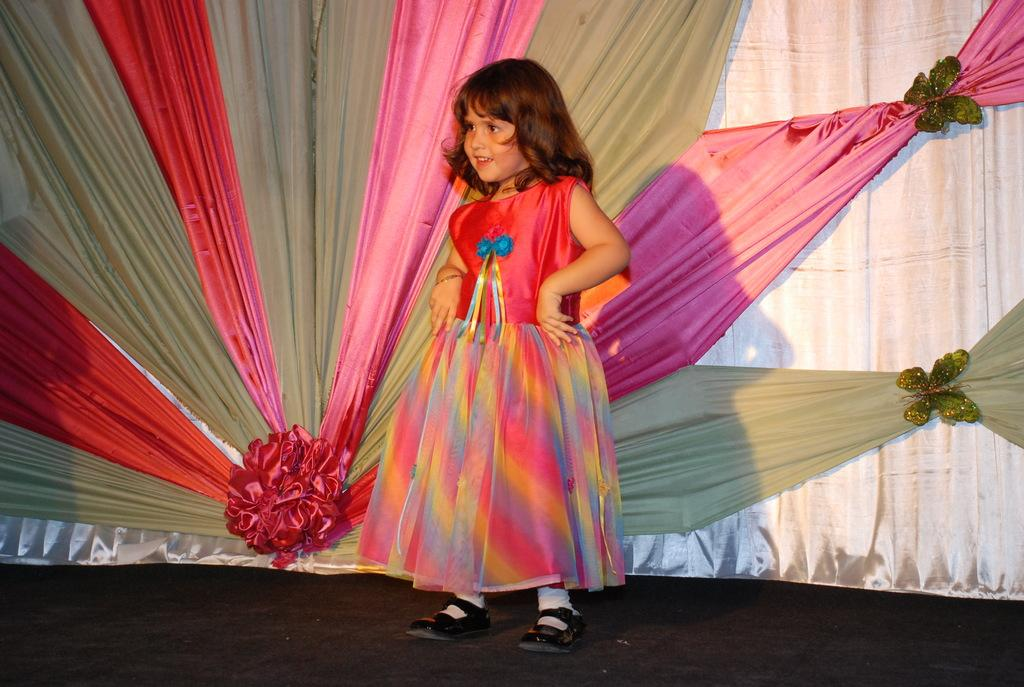Who is the main subject in the image? There is a girl in the image. What is the girl doing in the image? The girl is standing on the ground. What can be seen in the background of the image? There are curtains in the background of the image. What type of squirrel can be seen climbing the curtains in the image? There is no squirrel present in the image, and therefore no such activity can be observed. 